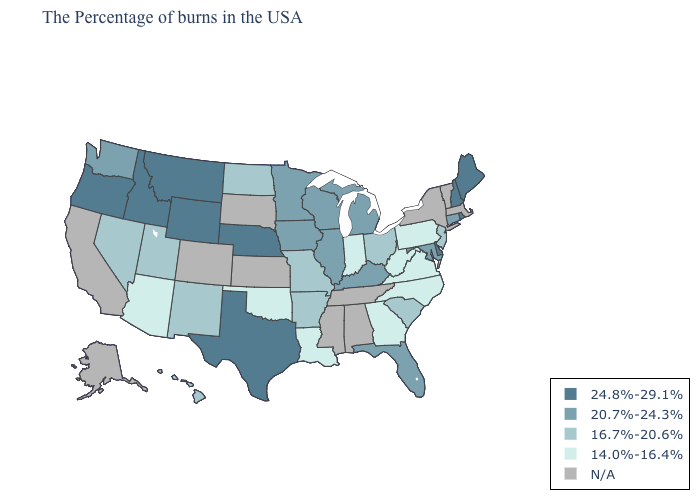Does Washington have the highest value in the West?
Write a very short answer. No. Among the states that border Michigan , which have the lowest value?
Give a very brief answer. Indiana. Name the states that have a value in the range N/A?
Quick response, please. Massachusetts, Vermont, New York, Alabama, Tennessee, Mississippi, Kansas, South Dakota, Colorado, California, Alaska. What is the lowest value in states that border Oklahoma?
Give a very brief answer. 16.7%-20.6%. What is the highest value in the West ?
Quick response, please. 24.8%-29.1%. Among the states that border Florida , which have the highest value?
Answer briefly. Georgia. Does Oregon have the lowest value in the West?
Keep it brief. No. Among the states that border Missouri , which have the highest value?
Keep it brief. Nebraska. Does the first symbol in the legend represent the smallest category?
Quick response, please. No. Name the states that have a value in the range 24.8%-29.1%?
Be succinct. Maine, Rhode Island, New Hampshire, Delaware, Nebraska, Texas, Wyoming, Montana, Idaho, Oregon. What is the highest value in the USA?
Write a very short answer. 24.8%-29.1%. Name the states that have a value in the range 24.8%-29.1%?
Short answer required. Maine, Rhode Island, New Hampshire, Delaware, Nebraska, Texas, Wyoming, Montana, Idaho, Oregon. Among the states that border New Jersey , which have the highest value?
Answer briefly. Delaware. What is the value of Alabama?
Concise answer only. N/A. Name the states that have a value in the range 20.7%-24.3%?
Concise answer only. Connecticut, Maryland, Florida, Michigan, Kentucky, Wisconsin, Illinois, Minnesota, Iowa, Washington. 